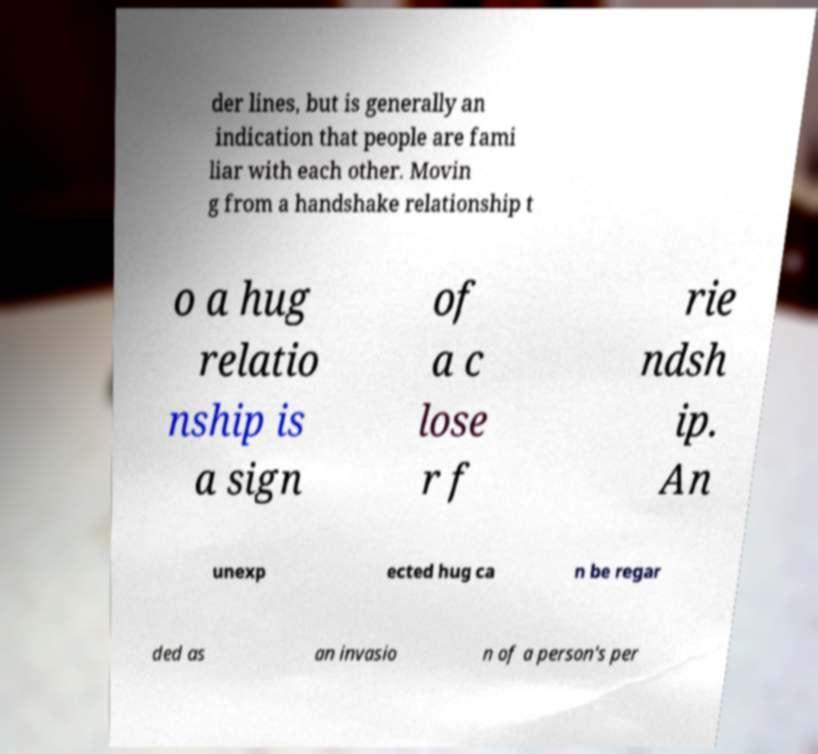Could you assist in decoding the text presented in this image and type it out clearly? der lines, but is generally an indication that people are fami liar with each other. Movin g from a handshake relationship t o a hug relatio nship is a sign of a c lose r f rie ndsh ip. An unexp ected hug ca n be regar ded as an invasio n of a person's per 